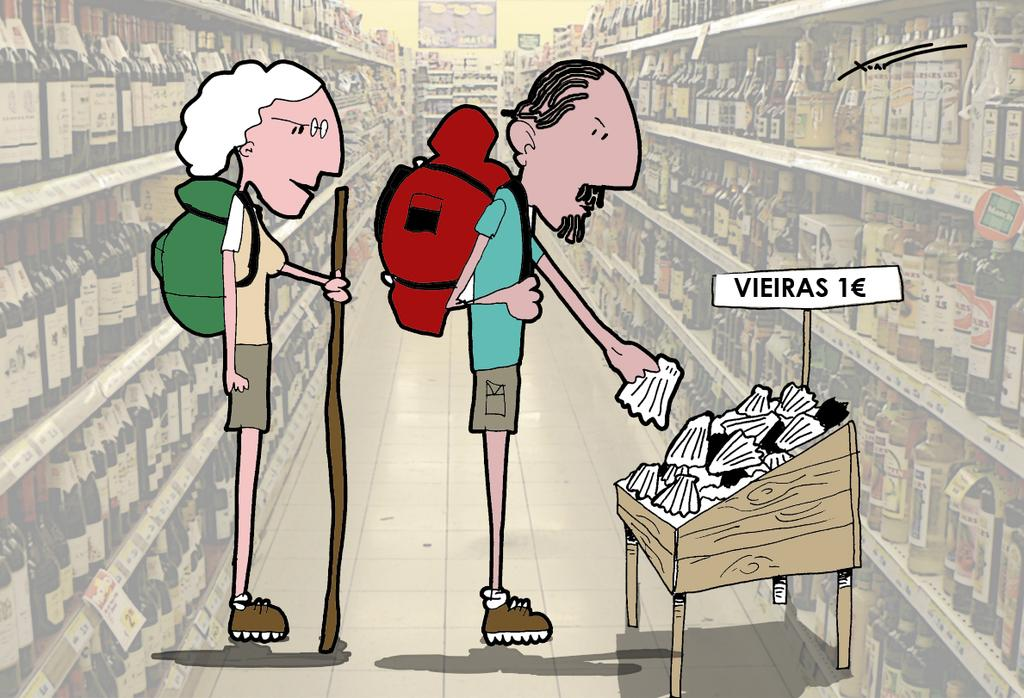What style is the image drawn in? The image is a cartoon sketch. How many people are in the image? There are two people in the image. What is one person doing in the image? One person is picking up an object. What can be seen on the wall in the image? There is a poster in the image. What is written on the poster? The poster has "VIERES 1 Euro" written on it. How many ladybugs are crawling on the oven in the image? There is no oven or ladybugs present in the image. 